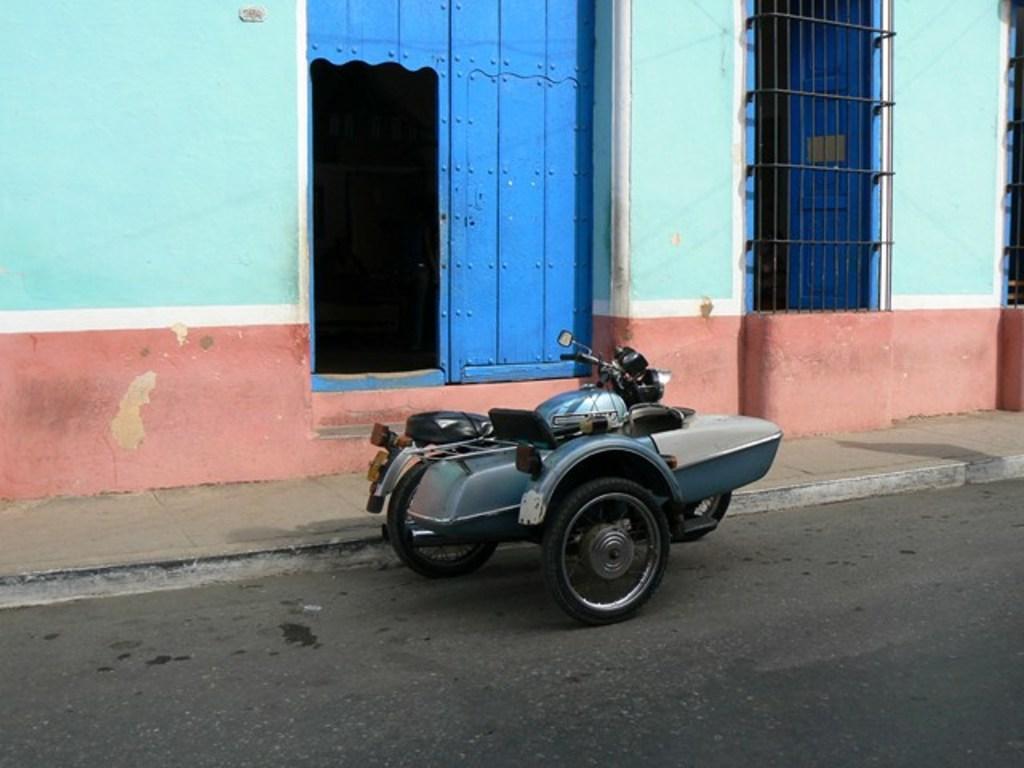Describe this image in one or two sentences. In this image, I can see the scooter with sidecar, which is parked beside the road. This is the wooden door, which is blue in color. I think this is the house with a window. This looks like an iron grill. Here is the road. 